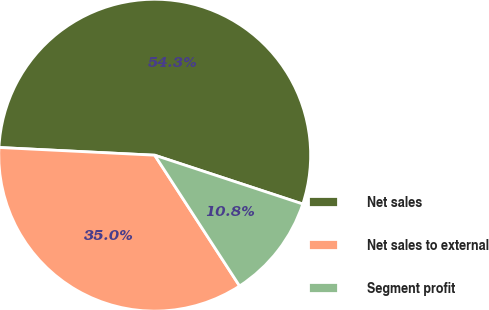Convert chart. <chart><loc_0><loc_0><loc_500><loc_500><pie_chart><fcel>Net sales<fcel>Net sales to external<fcel>Segment profit<nl><fcel>54.28%<fcel>34.95%<fcel>10.77%<nl></chart> 